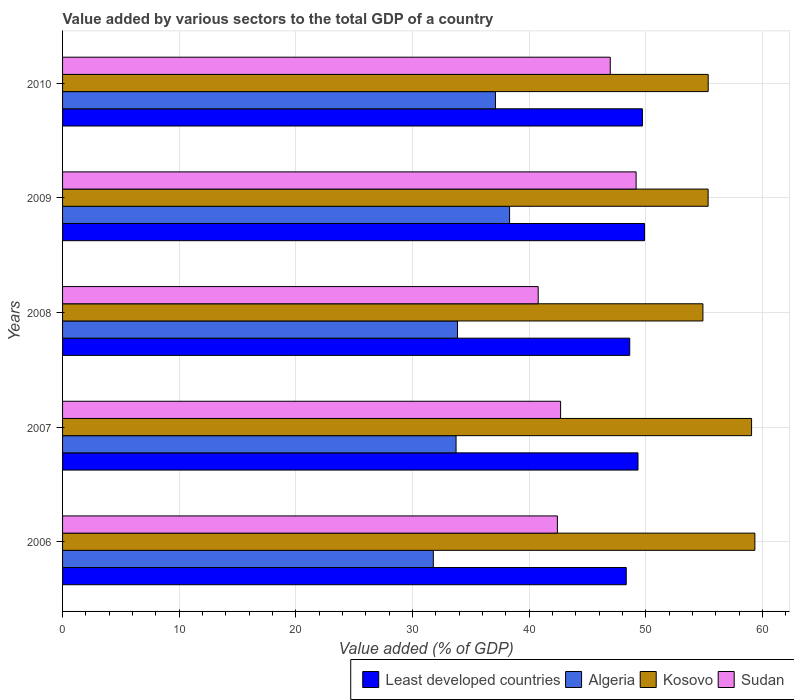How many different coloured bars are there?
Ensure brevity in your answer.  4. Are the number of bars on each tick of the Y-axis equal?
Provide a short and direct response. Yes. How many bars are there on the 4th tick from the top?
Provide a succinct answer. 4. In how many cases, is the number of bars for a given year not equal to the number of legend labels?
Ensure brevity in your answer.  0. What is the value added by various sectors to the total GDP in Algeria in 2007?
Give a very brief answer. 33.74. Across all years, what is the maximum value added by various sectors to the total GDP in Least developed countries?
Make the answer very short. 49.9. Across all years, what is the minimum value added by various sectors to the total GDP in Algeria?
Ensure brevity in your answer.  31.79. In which year was the value added by various sectors to the total GDP in Sudan maximum?
Give a very brief answer. 2009. What is the total value added by various sectors to the total GDP in Least developed countries in the graph?
Your response must be concise. 245.93. What is the difference between the value added by various sectors to the total GDP in Least developed countries in 2009 and that in 2010?
Make the answer very short. 0.18. What is the difference between the value added by various sectors to the total GDP in Kosovo in 2009 and the value added by various sectors to the total GDP in Algeria in 2007?
Provide a succinct answer. 21.61. What is the average value added by various sectors to the total GDP in Least developed countries per year?
Your answer should be very brief. 49.19. In the year 2009, what is the difference between the value added by various sectors to the total GDP in Algeria and value added by various sectors to the total GDP in Sudan?
Make the answer very short. -10.85. What is the ratio of the value added by various sectors to the total GDP in Least developed countries in 2007 to that in 2008?
Keep it short and to the point. 1.01. Is the difference between the value added by various sectors to the total GDP in Algeria in 2006 and 2007 greater than the difference between the value added by various sectors to the total GDP in Sudan in 2006 and 2007?
Your answer should be compact. No. What is the difference between the highest and the second highest value added by various sectors to the total GDP in Sudan?
Keep it short and to the point. 2.22. What is the difference between the highest and the lowest value added by various sectors to the total GDP in Sudan?
Your answer should be compact. 8.4. Is the sum of the value added by various sectors to the total GDP in Kosovo in 2006 and 2007 greater than the maximum value added by various sectors to the total GDP in Sudan across all years?
Give a very brief answer. Yes. Is it the case that in every year, the sum of the value added by various sectors to the total GDP in Least developed countries and value added by various sectors to the total GDP in Sudan is greater than the sum of value added by various sectors to the total GDP in Algeria and value added by various sectors to the total GDP in Kosovo?
Ensure brevity in your answer.  Yes. What does the 2nd bar from the top in 2010 represents?
Ensure brevity in your answer.  Kosovo. What does the 3rd bar from the bottom in 2010 represents?
Your answer should be very brief. Kosovo. Is it the case that in every year, the sum of the value added by various sectors to the total GDP in Kosovo and value added by various sectors to the total GDP in Sudan is greater than the value added by various sectors to the total GDP in Least developed countries?
Provide a succinct answer. Yes. Are all the bars in the graph horizontal?
Offer a very short reply. Yes. How many years are there in the graph?
Make the answer very short. 5. Are the values on the major ticks of X-axis written in scientific E-notation?
Your answer should be very brief. No. Does the graph contain any zero values?
Your answer should be very brief. No. How many legend labels are there?
Make the answer very short. 4. What is the title of the graph?
Provide a short and direct response. Value added by various sectors to the total GDP of a country. What is the label or title of the X-axis?
Provide a succinct answer. Value added (% of GDP). What is the Value added (% of GDP) of Least developed countries in 2006?
Ensure brevity in your answer.  48.33. What is the Value added (% of GDP) of Algeria in 2006?
Offer a very short reply. 31.79. What is the Value added (% of GDP) in Kosovo in 2006?
Provide a succinct answer. 59.36. What is the Value added (% of GDP) of Sudan in 2006?
Make the answer very short. 42.43. What is the Value added (% of GDP) in Least developed countries in 2007?
Your answer should be compact. 49.34. What is the Value added (% of GDP) of Algeria in 2007?
Provide a short and direct response. 33.74. What is the Value added (% of GDP) of Kosovo in 2007?
Make the answer very short. 59.08. What is the Value added (% of GDP) in Sudan in 2007?
Offer a very short reply. 42.7. What is the Value added (% of GDP) in Least developed countries in 2008?
Provide a short and direct response. 48.63. What is the Value added (% of GDP) of Algeria in 2008?
Provide a short and direct response. 33.86. What is the Value added (% of GDP) of Kosovo in 2008?
Provide a short and direct response. 54.91. What is the Value added (% of GDP) of Sudan in 2008?
Provide a succinct answer. 40.78. What is the Value added (% of GDP) of Least developed countries in 2009?
Your answer should be compact. 49.9. What is the Value added (% of GDP) in Algeria in 2009?
Offer a very short reply. 38.33. What is the Value added (% of GDP) of Kosovo in 2009?
Provide a succinct answer. 55.35. What is the Value added (% of GDP) of Sudan in 2009?
Make the answer very short. 49.18. What is the Value added (% of GDP) in Least developed countries in 2010?
Your answer should be compact. 49.72. What is the Value added (% of GDP) in Algeria in 2010?
Provide a short and direct response. 37.12. What is the Value added (% of GDP) in Kosovo in 2010?
Offer a very short reply. 55.36. What is the Value added (% of GDP) in Sudan in 2010?
Offer a terse response. 46.96. Across all years, what is the maximum Value added (% of GDP) in Least developed countries?
Make the answer very short. 49.9. Across all years, what is the maximum Value added (% of GDP) in Algeria?
Your response must be concise. 38.33. Across all years, what is the maximum Value added (% of GDP) in Kosovo?
Your response must be concise. 59.36. Across all years, what is the maximum Value added (% of GDP) of Sudan?
Your response must be concise. 49.18. Across all years, what is the minimum Value added (% of GDP) in Least developed countries?
Provide a succinct answer. 48.33. Across all years, what is the minimum Value added (% of GDP) in Algeria?
Keep it short and to the point. 31.79. Across all years, what is the minimum Value added (% of GDP) in Kosovo?
Make the answer very short. 54.91. Across all years, what is the minimum Value added (% of GDP) of Sudan?
Your answer should be compact. 40.78. What is the total Value added (% of GDP) in Least developed countries in the graph?
Provide a succinct answer. 245.93. What is the total Value added (% of GDP) of Algeria in the graph?
Give a very brief answer. 174.84. What is the total Value added (% of GDP) of Kosovo in the graph?
Your answer should be compact. 284.06. What is the total Value added (% of GDP) in Sudan in the graph?
Give a very brief answer. 222.06. What is the difference between the Value added (% of GDP) of Least developed countries in 2006 and that in 2007?
Provide a succinct answer. -1.01. What is the difference between the Value added (% of GDP) of Algeria in 2006 and that in 2007?
Offer a very short reply. -1.95. What is the difference between the Value added (% of GDP) in Kosovo in 2006 and that in 2007?
Your answer should be compact. 0.28. What is the difference between the Value added (% of GDP) of Sudan in 2006 and that in 2007?
Offer a terse response. -0.27. What is the difference between the Value added (% of GDP) of Least developed countries in 2006 and that in 2008?
Your answer should be compact. -0.3. What is the difference between the Value added (% of GDP) in Algeria in 2006 and that in 2008?
Make the answer very short. -2.07. What is the difference between the Value added (% of GDP) of Kosovo in 2006 and that in 2008?
Offer a terse response. 4.46. What is the difference between the Value added (% of GDP) of Sudan in 2006 and that in 2008?
Your response must be concise. 1.64. What is the difference between the Value added (% of GDP) of Least developed countries in 2006 and that in 2009?
Offer a terse response. -1.57. What is the difference between the Value added (% of GDP) of Algeria in 2006 and that in 2009?
Provide a succinct answer. -6.54. What is the difference between the Value added (% of GDP) in Kosovo in 2006 and that in 2009?
Ensure brevity in your answer.  4.01. What is the difference between the Value added (% of GDP) in Sudan in 2006 and that in 2009?
Keep it short and to the point. -6.75. What is the difference between the Value added (% of GDP) in Least developed countries in 2006 and that in 2010?
Keep it short and to the point. -1.39. What is the difference between the Value added (% of GDP) of Algeria in 2006 and that in 2010?
Offer a very short reply. -5.33. What is the difference between the Value added (% of GDP) in Kosovo in 2006 and that in 2010?
Provide a short and direct response. 4. What is the difference between the Value added (% of GDP) of Sudan in 2006 and that in 2010?
Make the answer very short. -4.53. What is the difference between the Value added (% of GDP) in Least developed countries in 2007 and that in 2008?
Offer a very short reply. 0.71. What is the difference between the Value added (% of GDP) of Algeria in 2007 and that in 2008?
Give a very brief answer. -0.12. What is the difference between the Value added (% of GDP) of Kosovo in 2007 and that in 2008?
Offer a terse response. 4.17. What is the difference between the Value added (% of GDP) in Sudan in 2007 and that in 2008?
Keep it short and to the point. 1.92. What is the difference between the Value added (% of GDP) of Least developed countries in 2007 and that in 2009?
Make the answer very short. -0.56. What is the difference between the Value added (% of GDP) in Algeria in 2007 and that in 2009?
Keep it short and to the point. -4.59. What is the difference between the Value added (% of GDP) in Kosovo in 2007 and that in 2009?
Give a very brief answer. 3.73. What is the difference between the Value added (% of GDP) of Sudan in 2007 and that in 2009?
Provide a succinct answer. -6.48. What is the difference between the Value added (% of GDP) in Least developed countries in 2007 and that in 2010?
Your answer should be compact. -0.38. What is the difference between the Value added (% of GDP) in Algeria in 2007 and that in 2010?
Your answer should be compact. -3.38. What is the difference between the Value added (% of GDP) in Kosovo in 2007 and that in 2010?
Your response must be concise. 3.72. What is the difference between the Value added (% of GDP) in Sudan in 2007 and that in 2010?
Give a very brief answer. -4.26. What is the difference between the Value added (% of GDP) of Least developed countries in 2008 and that in 2009?
Give a very brief answer. -1.27. What is the difference between the Value added (% of GDP) in Algeria in 2008 and that in 2009?
Your answer should be very brief. -4.47. What is the difference between the Value added (% of GDP) of Kosovo in 2008 and that in 2009?
Ensure brevity in your answer.  -0.45. What is the difference between the Value added (% of GDP) in Sudan in 2008 and that in 2009?
Ensure brevity in your answer.  -8.4. What is the difference between the Value added (% of GDP) of Least developed countries in 2008 and that in 2010?
Offer a terse response. -1.09. What is the difference between the Value added (% of GDP) of Algeria in 2008 and that in 2010?
Your response must be concise. -3.26. What is the difference between the Value added (% of GDP) in Kosovo in 2008 and that in 2010?
Ensure brevity in your answer.  -0.45. What is the difference between the Value added (% of GDP) of Sudan in 2008 and that in 2010?
Provide a succinct answer. -6.18. What is the difference between the Value added (% of GDP) in Least developed countries in 2009 and that in 2010?
Make the answer very short. 0.18. What is the difference between the Value added (% of GDP) in Algeria in 2009 and that in 2010?
Your answer should be very brief. 1.21. What is the difference between the Value added (% of GDP) in Kosovo in 2009 and that in 2010?
Your answer should be compact. -0.01. What is the difference between the Value added (% of GDP) of Sudan in 2009 and that in 2010?
Your response must be concise. 2.22. What is the difference between the Value added (% of GDP) in Least developed countries in 2006 and the Value added (% of GDP) in Algeria in 2007?
Ensure brevity in your answer.  14.59. What is the difference between the Value added (% of GDP) in Least developed countries in 2006 and the Value added (% of GDP) in Kosovo in 2007?
Ensure brevity in your answer.  -10.75. What is the difference between the Value added (% of GDP) of Least developed countries in 2006 and the Value added (% of GDP) of Sudan in 2007?
Ensure brevity in your answer.  5.63. What is the difference between the Value added (% of GDP) in Algeria in 2006 and the Value added (% of GDP) in Kosovo in 2007?
Your answer should be very brief. -27.29. What is the difference between the Value added (% of GDP) in Algeria in 2006 and the Value added (% of GDP) in Sudan in 2007?
Keep it short and to the point. -10.91. What is the difference between the Value added (% of GDP) of Kosovo in 2006 and the Value added (% of GDP) of Sudan in 2007?
Keep it short and to the point. 16.66. What is the difference between the Value added (% of GDP) of Least developed countries in 2006 and the Value added (% of GDP) of Algeria in 2008?
Your response must be concise. 14.47. What is the difference between the Value added (% of GDP) of Least developed countries in 2006 and the Value added (% of GDP) of Kosovo in 2008?
Give a very brief answer. -6.57. What is the difference between the Value added (% of GDP) of Least developed countries in 2006 and the Value added (% of GDP) of Sudan in 2008?
Offer a very short reply. 7.55. What is the difference between the Value added (% of GDP) in Algeria in 2006 and the Value added (% of GDP) in Kosovo in 2008?
Give a very brief answer. -23.12. What is the difference between the Value added (% of GDP) of Algeria in 2006 and the Value added (% of GDP) of Sudan in 2008?
Your response must be concise. -8.99. What is the difference between the Value added (% of GDP) in Kosovo in 2006 and the Value added (% of GDP) in Sudan in 2008?
Ensure brevity in your answer.  18.58. What is the difference between the Value added (% of GDP) of Least developed countries in 2006 and the Value added (% of GDP) of Algeria in 2009?
Make the answer very short. 10. What is the difference between the Value added (% of GDP) in Least developed countries in 2006 and the Value added (% of GDP) in Kosovo in 2009?
Make the answer very short. -7.02. What is the difference between the Value added (% of GDP) in Least developed countries in 2006 and the Value added (% of GDP) in Sudan in 2009?
Keep it short and to the point. -0.85. What is the difference between the Value added (% of GDP) in Algeria in 2006 and the Value added (% of GDP) in Kosovo in 2009?
Offer a terse response. -23.56. What is the difference between the Value added (% of GDP) in Algeria in 2006 and the Value added (% of GDP) in Sudan in 2009?
Make the answer very short. -17.39. What is the difference between the Value added (% of GDP) of Kosovo in 2006 and the Value added (% of GDP) of Sudan in 2009?
Provide a succinct answer. 10.18. What is the difference between the Value added (% of GDP) of Least developed countries in 2006 and the Value added (% of GDP) of Algeria in 2010?
Your answer should be very brief. 11.21. What is the difference between the Value added (% of GDP) in Least developed countries in 2006 and the Value added (% of GDP) in Kosovo in 2010?
Your response must be concise. -7.03. What is the difference between the Value added (% of GDP) of Least developed countries in 2006 and the Value added (% of GDP) of Sudan in 2010?
Offer a very short reply. 1.37. What is the difference between the Value added (% of GDP) of Algeria in 2006 and the Value added (% of GDP) of Kosovo in 2010?
Your response must be concise. -23.57. What is the difference between the Value added (% of GDP) in Algeria in 2006 and the Value added (% of GDP) in Sudan in 2010?
Give a very brief answer. -15.17. What is the difference between the Value added (% of GDP) of Kosovo in 2006 and the Value added (% of GDP) of Sudan in 2010?
Your answer should be very brief. 12.4. What is the difference between the Value added (% of GDP) of Least developed countries in 2007 and the Value added (% of GDP) of Algeria in 2008?
Your answer should be compact. 15.48. What is the difference between the Value added (% of GDP) of Least developed countries in 2007 and the Value added (% of GDP) of Kosovo in 2008?
Give a very brief answer. -5.57. What is the difference between the Value added (% of GDP) in Least developed countries in 2007 and the Value added (% of GDP) in Sudan in 2008?
Offer a terse response. 8.56. What is the difference between the Value added (% of GDP) of Algeria in 2007 and the Value added (% of GDP) of Kosovo in 2008?
Give a very brief answer. -21.17. What is the difference between the Value added (% of GDP) in Algeria in 2007 and the Value added (% of GDP) in Sudan in 2008?
Provide a short and direct response. -7.04. What is the difference between the Value added (% of GDP) of Kosovo in 2007 and the Value added (% of GDP) of Sudan in 2008?
Give a very brief answer. 18.29. What is the difference between the Value added (% of GDP) of Least developed countries in 2007 and the Value added (% of GDP) of Algeria in 2009?
Provide a succinct answer. 11.01. What is the difference between the Value added (% of GDP) in Least developed countries in 2007 and the Value added (% of GDP) in Kosovo in 2009?
Offer a terse response. -6.01. What is the difference between the Value added (% of GDP) in Least developed countries in 2007 and the Value added (% of GDP) in Sudan in 2009?
Offer a very short reply. 0.16. What is the difference between the Value added (% of GDP) in Algeria in 2007 and the Value added (% of GDP) in Kosovo in 2009?
Provide a short and direct response. -21.61. What is the difference between the Value added (% of GDP) in Algeria in 2007 and the Value added (% of GDP) in Sudan in 2009?
Keep it short and to the point. -15.44. What is the difference between the Value added (% of GDP) of Kosovo in 2007 and the Value added (% of GDP) of Sudan in 2009?
Your answer should be very brief. 9.9. What is the difference between the Value added (% of GDP) of Least developed countries in 2007 and the Value added (% of GDP) of Algeria in 2010?
Give a very brief answer. 12.22. What is the difference between the Value added (% of GDP) in Least developed countries in 2007 and the Value added (% of GDP) in Kosovo in 2010?
Your answer should be very brief. -6.02. What is the difference between the Value added (% of GDP) in Least developed countries in 2007 and the Value added (% of GDP) in Sudan in 2010?
Offer a terse response. 2.38. What is the difference between the Value added (% of GDP) in Algeria in 2007 and the Value added (% of GDP) in Kosovo in 2010?
Keep it short and to the point. -21.62. What is the difference between the Value added (% of GDP) in Algeria in 2007 and the Value added (% of GDP) in Sudan in 2010?
Your answer should be compact. -13.22. What is the difference between the Value added (% of GDP) of Kosovo in 2007 and the Value added (% of GDP) of Sudan in 2010?
Your answer should be compact. 12.12. What is the difference between the Value added (% of GDP) in Least developed countries in 2008 and the Value added (% of GDP) in Algeria in 2009?
Your answer should be very brief. 10.3. What is the difference between the Value added (% of GDP) in Least developed countries in 2008 and the Value added (% of GDP) in Kosovo in 2009?
Ensure brevity in your answer.  -6.72. What is the difference between the Value added (% of GDP) of Least developed countries in 2008 and the Value added (% of GDP) of Sudan in 2009?
Provide a short and direct response. -0.55. What is the difference between the Value added (% of GDP) of Algeria in 2008 and the Value added (% of GDP) of Kosovo in 2009?
Make the answer very short. -21.49. What is the difference between the Value added (% of GDP) in Algeria in 2008 and the Value added (% of GDP) in Sudan in 2009?
Your answer should be compact. -15.32. What is the difference between the Value added (% of GDP) of Kosovo in 2008 and the Value added (% of GDP) of Sudan in 2009?
Make the answer very short. 5.73. What is the difference between the Value added (% of GDP) of Least developed countries in 2008 and the Value added (% of GDP) of Algeria in 2010?
Provide a short and direct response. 11.51. What is the difference between the Value added (% of GDP) in Least developed countries in 2008 and the Value added (% of GDP) in Kosovo in 2010?
Your answer should be very brief. -6.73. What is the difference between the Value added (% of GDP) in Least developed countries in 2008 and the Value added (% of GDP) in Sudan in 2010?
Provide a succinct answer. 1.67. What is the difference between the Value added (% of GDP) in Algeria in 2008 and the Value added (% of GDP) in Kosovo in 2010?
Make the answer very short. -21.5. What is the difference between the Value added (% of GDP) of Algeria in 2008 and the Value added (% of GDP) of Sudan in 2010?
Make the answer very short. -13.1. What is the difference between the Value added (% of GDP) of Kosovo in 2008 and the Value added (% of GDP) of Sudan in 2010?
Give a very brief answer. 7.94. What is the difference between the Value added (% of GDP) in Least developed countries in 2009 and the Value added (% of GDP) in Algeria in 2010?
Your answer should be very brief. 12.79. What is the difference between the Value added (% of GDP) in Least developed countries in 2009 and the Value added (% of GDP) in Kosovo in 2010?
Your answer should be very brief. -5.46. What is the difference between the Value added (% of GDP) of Least developed countries in 2009 and the Value added (% of GDP) of Sudan in 2010?
Offer a very short reply. 2.94. What is the difference between the Value added (% of GDP) of Algeria in 2009 and the Value added (% of GDP) of Kosovo in 2010?
Provide a succinct answer. -17.03. What is the difference between the Value added (% of GDP) of Algeria in 2009 and the Value added (% of GDP) of Sudan in 2010?
Ensure brevity in your answer.  -8.63. What is the difference between the Value added (% of GDP) of Kosovo in 2009 and the Value added (% of GDP) of Sudan in 2010?
Your response must be concise. 8.39. What is the average Value added (% of GDP) of Least developed countries per year?
Make the answer very short. 49.19. What is the average Value added (% of GDP) in Algeria per year?
Offer a very short reply. 34.97. What is the average Value added (% of GDP) in Kosovo per year?
Provide a succinct answer. 56.81. What is the average Value added (% of GDP) of Sudan per year?
Give a very brief answer. 44.41. In the year 2006, what is the difference between the Value added (% of GDP) in Least developed countries and Value added (% of GDP) in Algeria?
Your response must be concise. 16.54. In the year 2006, what is the difference between the Value added (% of GDP) in Least developed countries and Value added (% of GDP) in Kosovo?
Offer a very short reply. -11.03. In the year 2006, what is the difference between the Value added (% of GDP) in Least developed countries and Value added (% of GDP) in Sudan?
Your response must be concise. 5.9. In the year 2006, what is the difference between the Value added (% of GDP) of Algeria and Value added (% of GDP) of Kosovo?
Ensure brevity in your answer.  -27.57. In the year 2006, what is the difference between the Value added (% of GDP) of Algeria and Value added (% of GDP) of Sudan?
Your response must be concise. -10.64. In the year 2006, what is the difference between the Value added (% of GDP) of Kosovo and Value added (% of GDP) of Sudan?
Offer a terse response. 16.93. In the year 2007, what is the difference between the Value added (% of GDP) in Least developed countries and Value added (% of GDP) in Algeria?
Make the answer very short. 15.6. In the year 2007, what is the difference between the Value added (% of GDP) of Least developed countries and Value added (% of GDP) of Kosovo?
Your answer should be very brief. -9.74. In the year 2007, what is the difference between the Value added (% of GDP) in Least developed countries and Value added (% of GDP) in Sudan?
Provide a short and direct response. 6.64. In the year 2007, what is the difference between the Value added (% of GDP) in Algeria and Value added (% of GDP) in Kosovo?
Provide a short and direct response. -25.34. In the year 2007, what is the difference between the Value added (% of GDP) in Algeria and Value added (% of GDP) in Sudan?
Provide a succinct answer. -8.96. In the year 2007, what is the difference between the Value added (% of GDP) in Kosovo and Value added (% of GDP) in Sudan?
Offer a very short reply. 16.38. In the year 2008, what is the difference between the Value added (% of GDP) of Least developed countries and Value added (% of GDP) of Algeria?
Keep it short and to the point. 14.77. In the year 2008, what is the difference between the Value added (% of GDP) of Least developed countries and Value added (% of GDP) of Kosovo?
Your answer should be very brief. -6.28. In the year 2008, what is the difference between the Value added (% of GDP) in Least developed countries and Value added (% of GDP) in Sudan?
Your response must be concise. 7.85. In the year 2008, what is the difference between the Value added (% of GDP) in Algeria and Value added (% of GDP) in Kosovo?
Your response must be concise. -21.04. In the year 2008, what is the difference between the Value added (% of GDP) of Algeria and Value added (% of GDP) of Sudan?
Provide a succinct answer. -6.92. In the year 2008, what is the difference between the Value added (% of GDP) of Kosovo and Value added (% of GDP) of Sudan?
Give a very brief answer. 14.12. In the year 2009, what is the difference between the Value added (% of GDP) of Least developed countries and Value added (% of GDP) of Algeria?
Offer a very short reply. 11.57. In the year 2009, what is the difference between the Value added (% of GDP) of Least developed countries and Value added (% of GDP) of Kosovo?
Ensure brevity in your answer.  -5.45. In the year 2009, what is the difference between the Value added (% of GDP) in Least developed countries and Value added (% of GDP) in Sudan?
Provide a short and direct response. 0.72. In the year 2009, what is the difference between the Value added (% of GDP) of Algeria and Value added (% of GDP) of Kosovo?
Make the answer very short. -17.02. In the year 2009, what is the difference between the Value added (% of GDP) in Algeria and Value added (% of GDP) in Sudan?
Make the answer very short. -10.85. In the year 2009, what is the difference between the Value added (% of GDP) in Kosovo and Value added (% of GDP) in Sudan?
Offer a very short reply. 6.17. In the year 2010, what is the difference between the Value added (% of GDP) of Least developed countries and Value added (% of GDP) of Algeria?
Your answer should be compact. 12.6. In the year 2010, what is the difference between the Value added (% of GDP) in Least developed countries and Value added (% of GDP) in Kosovo?
Your answer should be compact. -5.64. In the year 2010, what is the difference between the Value added (% of GDP) in Least developed countries and Value added (% of GDP) in Sudan?
Keep it short and to the point. 2.76. In the year 2010, what is the difference between the Value added (% of GDP) in Algeria and Value added (% of GDP) in Kosovo?
Keep it short and to the point. -18.24. In the year 2010, what is the difference between the Value added (% of GDP) in Algeria and Value added (% of GDP) in Sudan?
Offer a terse response. -9.84. In the year 2010, what is the difference between the Value added (% of GDP) of Kosovo and Value added (% of GDP) of Sudan?
Give a very brief answer. 8.4. What is the ratio of the Value added (% of GDP) of Least developed countries in 2006 to that in 2007?
Offer a very short reply. 0.98. What is the ratio of the Value added (% of GDP) of Algeria in 2006 to that in 2007?
Your answer should be very brief. 0.94. What is the ratio of the Value added (% of GDP) in Kosovo in 2006 to that in 2007?
Offer a terse response. 1. What is the ratio of the Value added (% of GDP) in Least developed countries in 2006 to that in 2008?
Your answer should be very brief. 0.99. What is the ratio of the Value added (% of GDP) of Algeria in 2006 to that in 2008?
Give a very brief answer. 0.94. What is the ratio of the Value added (% of GDP) of Kosovo in 2006 to that in 2008?
Ensure brevity in your answer.  1.08. What is the ratio of the Value added (% of GDP) in Sudan in 2006 to that in 2008?
Keep it short and to the point. 1.04. What is the ratio of the Value added (% of GDP) of Least developed countries in 2006 to that in 2009?
Ensure brevity in your answer.  0.97. What is the ratio of the Value added (% of GDP) in Algeria in 2006 to that in 2009?
Your answer should be very brief. 0.83. What is the ratio of the Value added (% of GDP) in Kosovo in 2006 to that in 2009?
Offer a very short reply. 1.07. What is the ratio of the Value added (% of GDP) of Sudan in 2006 to that in 2009?
Provide a succinct answer. 0.86. What is the ratio of the Value added (% of GDP) of Least developed countries in 2006 to that in 2010?
Offer a very short reply. 0.97. What is the ratio of the Value added (% of GDP) of Algeria in 2006 to that in 2010?
Your answer should be very brief. 0.86. What is the ratio of the Value added (% of GDP) in Kosovo in 2006 to that in 2010?
Keep it short and to the point. 1.07. What is the ratio of the Value added (% of GDP) of Sudan in 2006 to that in 2010?
Provide a succinct answer. 0.9. What is the ratio of the Value added (% of GDP) in Least developed countries in 2007 to that in 2008?
Provide a short and direct response. 1.01. What is the ratio of the Value added (% of GDP) of Kosovo in 2007 to that in 2008?
Your answer should be very brief. 1.08. What is the ratio of the Value added (% of GDP) in Sudan in 2007 to that in 2008?
Your response must be concise. 1.05. What is the ratio of the Value added (% of GDP) in Least developed countries in 2007 to that in 2009?
Your answer should be compact. 0.99. What is the ratio of the Value added (% of GDP) of Algeria in 2007 to that in 2009?
Your answer should be very brief. 0.88. What is the ratio of the Value added (% of GDP) in Kosovo in 2007 to that in 2009?
Your answer should be very brief. 1.07. What is the ratio of the Value added (% of GDP) of Sudan in 2007 to that in 2009?
Offer a very short reply. 0.87. What is the ratio of the Value added (% of GDP) in Least developed countries in 2007 to that in 2010?
Keep it short and to the point. 0.99. What is the ratio of the Value added (% of GDP) of Algeria in 2007 to that in 2010?
Offer a terse response. 0.91. What is the ratio of the Value added (% of GDP) in Kosovo in 2007 to that in 2010?
Offer a very short reply. 1.07. What is the ratio of the Value added (% of GDP) in Sudan in 2007 to that in 2010?
Ensure brevity in your answer.  0.91. What is the ratio of the Value added (% of GDP) in Least developed countries in 2008 to that in 2009?
Offer a very short reply. 0.97. What is the ratio of the Value added (% of GDP) of Algeria in 2008 to that in 2009?
Your response must be concise. 0.88. What is the ratio of the Value added (% of GDP) of Sudan in 2008 to that in 2009?
Keep it short and to the point. 0.83. What is the ratio of the Value added (% of GDP) in Least developed countries in 2008 to that in 2010?
Your response must be concise. 0.98. What is the ratio of the Value added (% of GDP) of Algeria in 2008 to that in 2010?
Provide a short and direct response. 0.91. What is the ratio of the Value added (% of GDP) in Kosovo in 2008 to that in 2010?
Ensure brevity in your answer.  0.99. What is the ratio of the Value added (% of GDP) in Sudan in 2008 to that in 2010?
Ensure brevity in your answer.  0.87. What is the ratio of the Value added (% of GDP) of Least developed countries in 2009 to that in 2010?
Your answer should be compact. 1. What is the ratio of the Value added (% of GDP) in Algeria in 2009 to that in 2010?
Your answer should be very brief. 1.03. What is the ratio of the Value added (% of GDP) in Sudan in 2009 to that in 2010?
Provide a succinct answer. 1.05. What is the difference between the highest and the second highest Value added (% of GDP) of Least developed countries?
Your answer should be very brief. 0.18. What is the difference between the highest and the second highest Value added (% of GDP) in Algeria?
Offer a terse response. 1.21. What is the difference between the highest and the second highest Value added (% of GDP) in Kosovo?
Your response must be concise. 0.28. What is the difference between the highest and the second highest Value added (% of GDP) in Sudan?
Give a very brief answer. 2.22. What is the difference between the highest and the lowest Value added (% of GDP) in Least developed countries?
Give a very brief answer. 1.57. What is the difference between the highest and the lowest Value added (% of GDP) in Algeria?
Your answer should be compact. 6.54. What is the difference between the highest and the lowest Value added (% of GDP) of Kosovo?
Give a very brief answer. 4.46. What is the difference between the highest and the lowest Value added (% of GDP) of Sudan?
Provide a short and direct response. 8.4. 